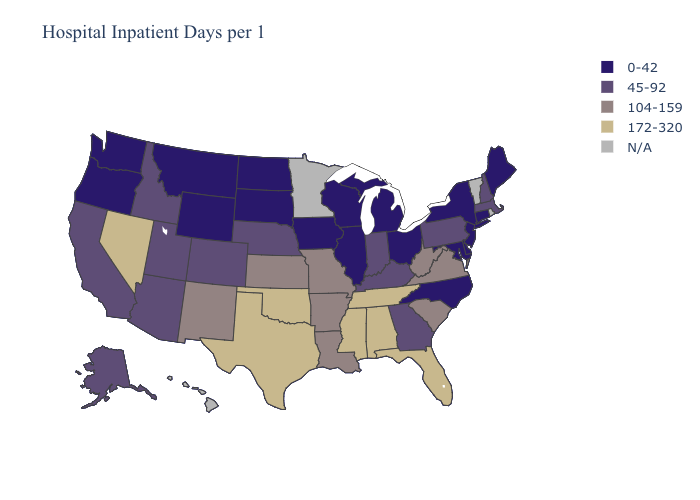Name the states that have a value in the range 172-320?
Be succinct. Alabama, Florida, Mississippi, Nevada, Oklahoma, Tennessee, Texas. Name the states that have a value in the range 172-320?
Give a very brief answer. Alabama, Florida, Mississippi, Nevada, Oklahoma, Tennessee, Texas. Name the states that have a value in the range 45-92?
Keep it brief. Alaska, Arizona, California, Colorado, Georgia, Idaho, Indiana, Kentucky, Massachusetts, Nebraska, New Hampshire, Pennsylvania, Utah. Does the map have missing data?
Quick response, please. Yes. Does Oklahoma have the highest value in the USA?
Concise answer only. Yes. What is the value of Wyoming?
Answer briefly. 0-42. What is the lowest value in the South?
Be succinct. 0-42. What is the value of Rhode Island?
Be succinct. N/A. Among the states that border Kansas , does Colorado have the highest value?
Be succinct. No. Does Oklahoma have the lowest value in the USA?
Short answer required. No. Name the states that have a value in the range 0-42?
Short answer required. Connecticut, Delaware, Illinois, Iowa, Maine, Maryland, Michigan, Montana, New Jersey, New York, North Carolina, North Dakota, Ohio, Oregon, South Dakota, Washington, Wisconsin, Wyoming. Name the states that have a value in the range 45-92?
Answer briefly. Alaska, Arizona, California, Colorado, Georgia, Idaho, Indiana, Kentucky, Massachusetts, Nebraska, New Hampshire, Pennsylvania, Utah. Does the map have missing data?
Give a very brief answer. Yes. Among the states that border New Mexico , which have the lowest value?
Concise answer only. Arizona, Colorado, Utah. 